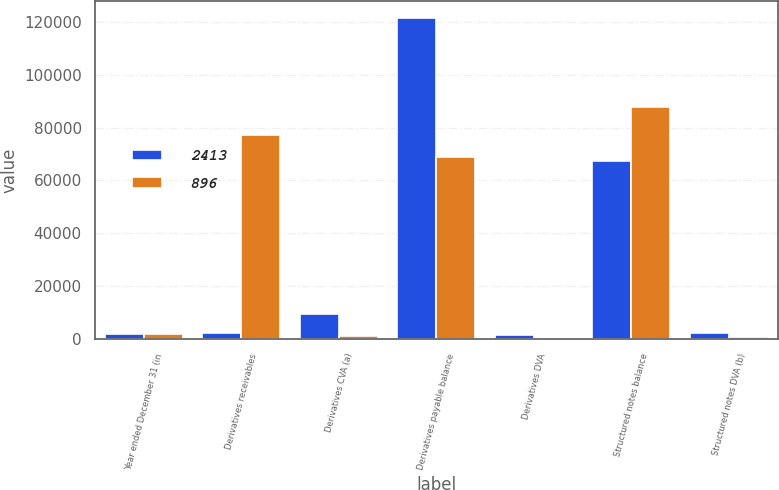<chart> <loc_0><loc_0><loc_500><loc_500><stacked_bar_chart><ecel><fcel>Year ended December 31 (in<fcel>Derivatives receivables<fcel>Derivatives CVA (a)<fcel>Derivatives payable balance<fcel>Derivatives DVA<fcel>Structured notes balance<fcel>Structured notes DVA (b)<nl><fcel>2413<fcel>2008<fcel>2413<fcel>9566<fcel>121604<fcel>1389<fcel>67340<fcel>2413<nl><fcel>896<fcel>2007<fcel>77136<fcel>1265<fcel>68705<fcel>518<fcel>87622<fcel>896<nl></chart> 